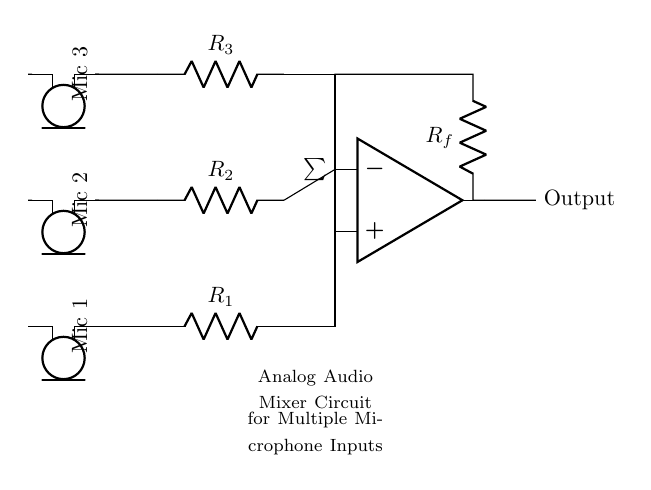What components are used for input signals? The circuit uses three microphone components for input signals. Each microphone is marked in the circuit diagram and connected to the input paths.
Answer: Three microphones What is the function of the resistors labeled R1, R2, and R3? The resistors R1, R2, and R3 are used to limit the current from each microphone and help in mixing the audio signals. They ensure that the levels from each mic are modulated before reaching the summing operational amplifier.
Answer: Current limiting What is the role of the operational amplifier in this circuit? The operational amplifier in the circuit sums the audio signals from the three microphones, which allows for a combined output signal. It effectively adds the input signals together to create a single mixed audio output.
Answer: Summing How many microphone inputs are combined into one output? The circuit combines three microphone inputs into one output signal via the summing operational amplifier, which takes the multiple inputs and produces a single output.
Answer: Three inputs What does the feedback resistor labeled Rf do? The feedback resistor Rf is connected from the output of the operational amplifier to its inverting input. It stabilizes the gain of the amplifier and controls how much of the output is fed back into the input for proper mixing and signal integrity.
Answer: Stabilizes gain What is the output of this circuit? The output of the circuit is a mixed audio signal that combines the inputs from the three microphones into one single output, allowing for easier management of the audio signals.
Answer: Mixed audio signal 